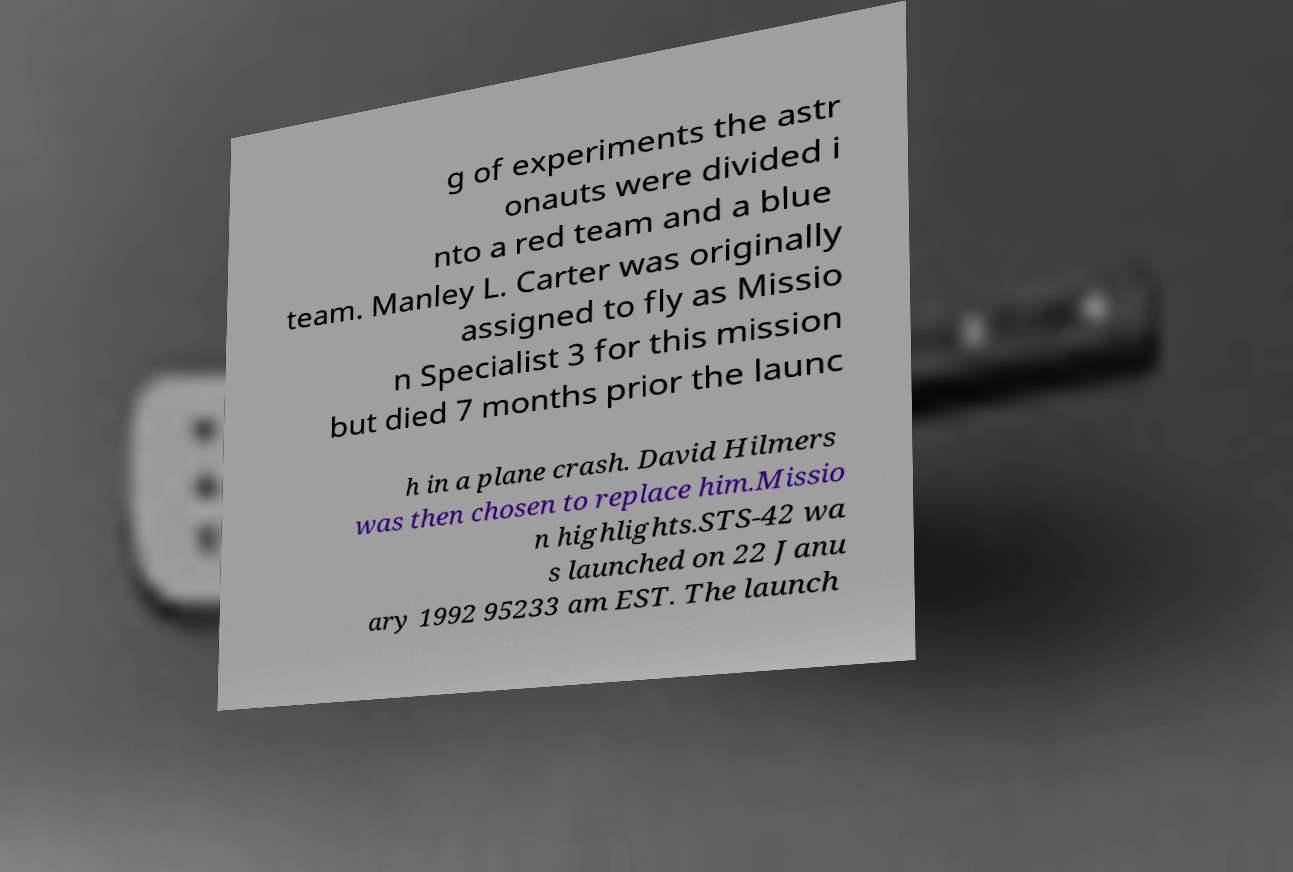What messages or text are displayed in this image? I need them in a readable, typed format. g of experiments the astr onauts were divided i nto a red team and a blue team. Manley L. Carter was originally assigned to fly as Missio n Specialist 3 for this mission but died 7 months prior the launc h in a plane crash. David Hilmers was then chosen to replace him.Missio n highlights.STS-42 wa s launched on 22 Janu ary 1992 95233 am EST. The launch 